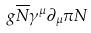<formula> <loc_0><loc_0><loc_500><loc_500>g \overline { N } \gamma ^ { \mu } \partial _ { \mu } \pi N</formula> 